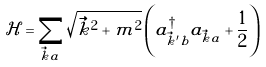Convert formula to latex. <formula><loc_0><loc_0><loc_500><loc_500>\mathcal { H } = \sum _ { \vec { k } a } \sqrt { \vec { k } ^ { 2 } + m ^ { 2 } } \left ( a _ { \vec { k } ^ { \prime } b } ^ { \dagger } a _ { \vec { k } a } + \frac { 1 } { 2 } \right )</formula> 